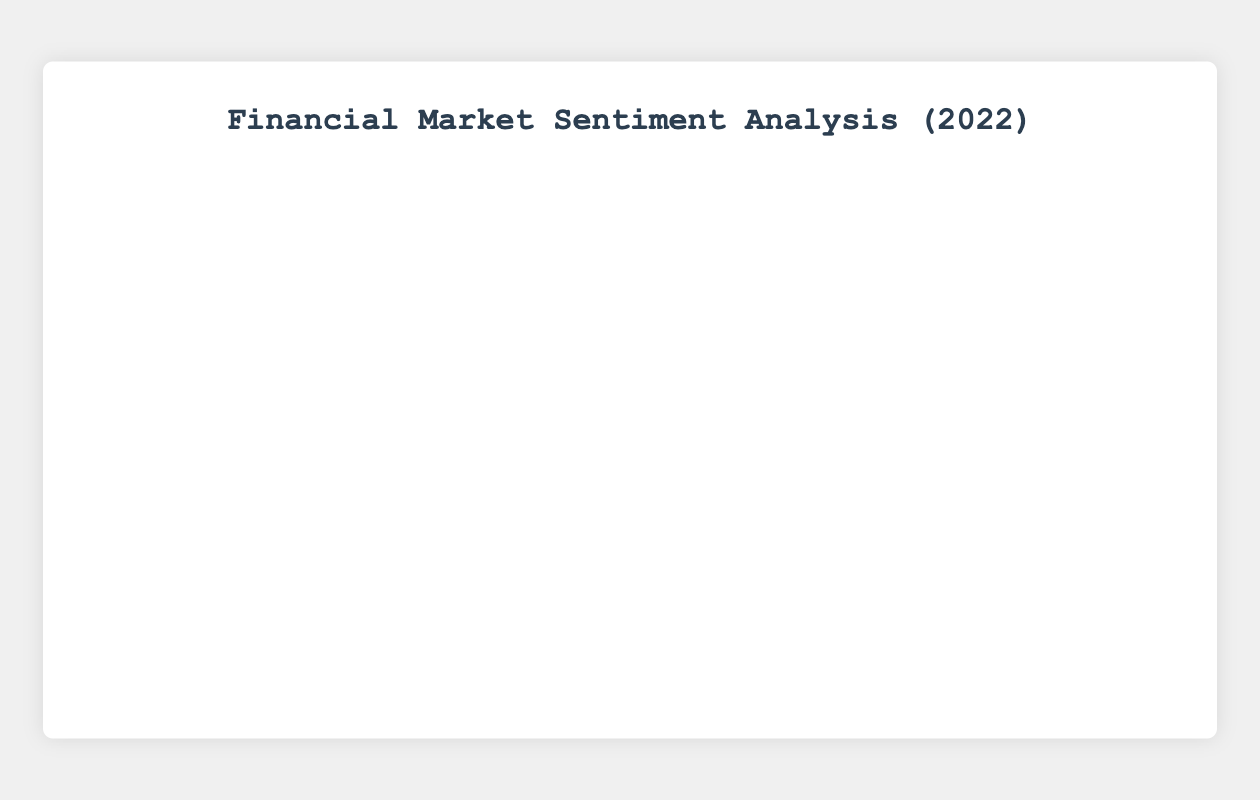What was the sentiment score on January 18, 2022, and which source provided it? Find the date "2022-01-18" on the x-axis. Observe the point's sentiment score and its color. From the graph, the sentiment score is 0.09, and the point color represents WSJ.
Answer: 0.09, WSJ Which news source had the highest sentiment score and what was the score? Identify the highest point on the y-axis and note its associated color. The highest sentiment score is 0.12, represented by the color of WSJ (green).
Answer: WSJ, 0.12 On how many days did Reuters report a positive sentiment score? Count the points associated with Reuters' color (red) that are above the x-axis (positive sentiment score): 2022-01-01, 2022-01-11, 2022-01-15, 2022-01-27.
Answer: 4 What is the range of sentiment scores observed from Bloomberg data points? Identify the points associated with Bloomberg's color (blue) and note the minimum and maximum scores: The lowest is -0.04, and the highest is 0.05. Calculate the range: 0.05 - (-0.04) = 0.09.
Answer: 0.09 Which day had the lowest sentiment score, and which source reported it? Identify the lowest point on the y-axis (most negative sentiment score). The lowest score is -0.07 on January 30, represented by the color of WSJ (green).
Answer: January 30, WSJ What is the average sentiment score reported by AP News? Identify all points associated with AP News' color (yellow): 2022-01-03 (0.10), 2022-01-09 (-0.05), 2022-01-13 (0.08), 2022-01-17 (-0.06), 2022-01-21 (-0.03), 2022-01-25 (0.07), 2022-01-29 (0.01). Calculate the average: (0.10 - 0.05 + 0.08 - 0.06 - 0.03 + 0.07 + 0.01) / 7 = 0.0171.
Answer: 0.0171 Compare the sentiment scores trends reported by Reuters and Bloomberg in the first seven days of January. Identify all points and their trends for Reuters (red): 0.05 on 2022-01-01, -0.04 on 2022-01-04, -0.01 on 2022-01-07. For Bloomberg (blue): -0.02 on 2022-01-02, 0.03 on 2022-01-05, 0.00 on 2022-01-08. Reuters start positive, drop, then slightly recover negative while Bloomberg goes from negative to positive then neutral.
Answer: Reuters: fluctuation, Bloomberg: U-shaped Between Reuters and WSJ, which source shows greater volatility in sentiment scores? Calculate the variance for each source's sentiment scores: Reuters (red): 0.05, -0.04, -0.01, 0.02, -0.01, 0.00, 0.03, 0.02 = Variance; WSJ (green): 0.12, 0.07, -0.02, 0.09, 0.05, -0.07 = Variance. Compare these variances to determine greater volatility.
Answer: WSJ What visual trend is observed in sentiment scores over time? Look at the pattern of up and down movements in the graph over time. There is no consistent trend; sentiment scores fluctuate throughout the period.
Answer: Fluctuation What color represents the sentiment scores reported by AP News, and how can you distinguish these points from others? The color representing AP News is yellow. These points can be distinguished by their unique yellow color and the tooltip information showing the source.
Answer: Yellow 